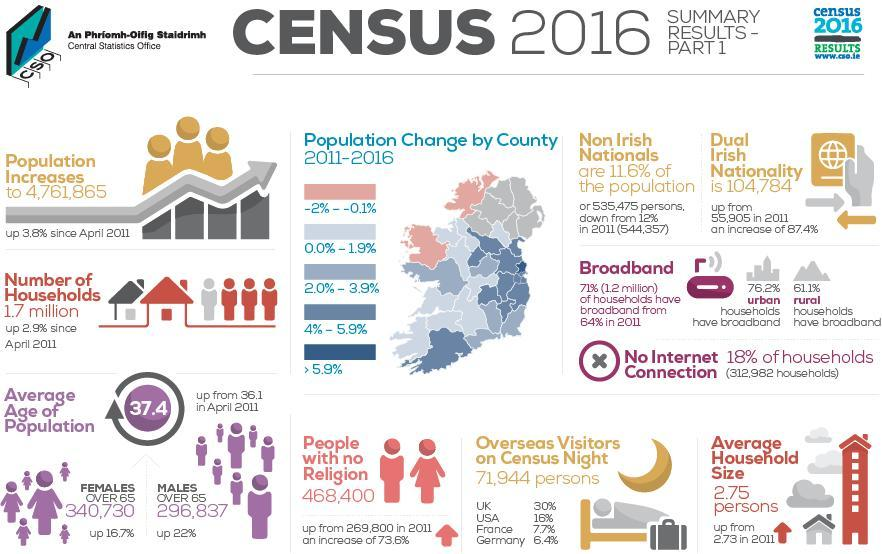What is the percentage increase of people with no religion in 2011, 6.4%, 7.7%, or & 73.6%?
Answer the question with a short phrase. 73.6% What is the percentage decrease in non-Irish Nationals from the population since 2011? 0.4% What is the increase in the count of number female senior citizens in comparison to the males ? 43,893 What is the percentage difference in urban and rural households having broad band? 15.1% How many counties have recorded a rise in population percentage of more than 5.9? 1 How many counties in Ireland have negative population percentage change in 2011- 2016? 2 